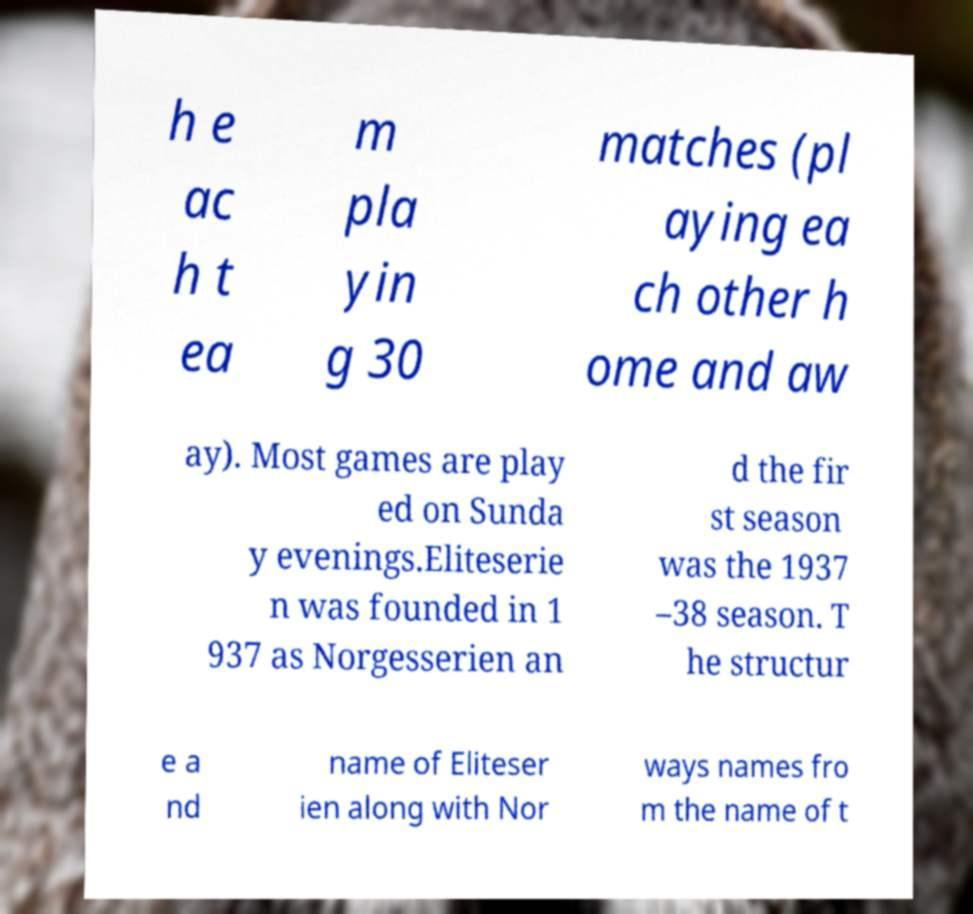Can you accurately transcribe the text from the provided image for me? h e ac h t ea m pla yin g 30 matches (pl aying ea ch other h ome and aw ay). Most games are play ed on Sunda y evenings.Eliteserie n was founded in 1 937 as Norgesserien an d the fir st season was the 1937 –38 season. T he structur e a nd name of Eliteser ien along with Nor ways names fro m the name of t 